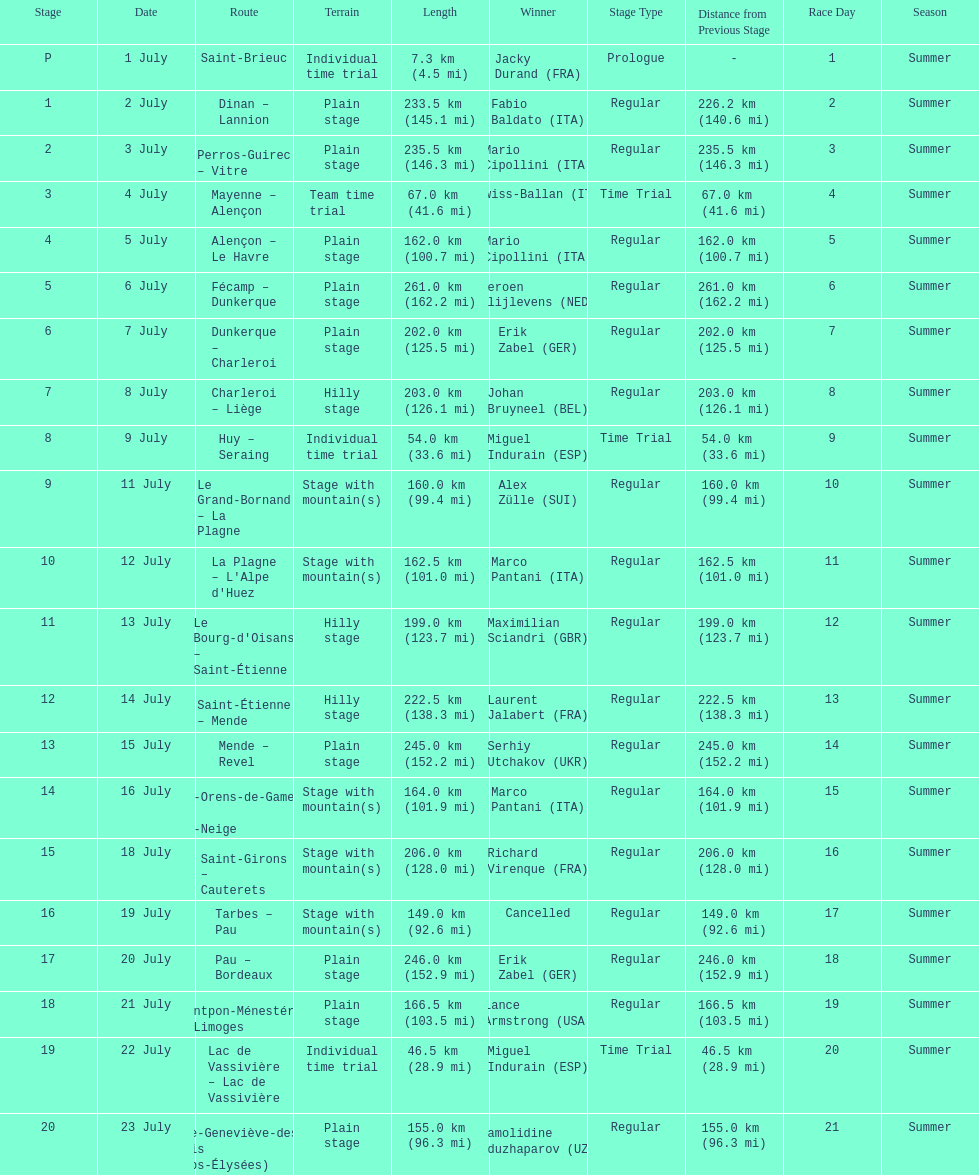How many consecutive km were raced on july 8th? 203.0 km (126.1 mi). 